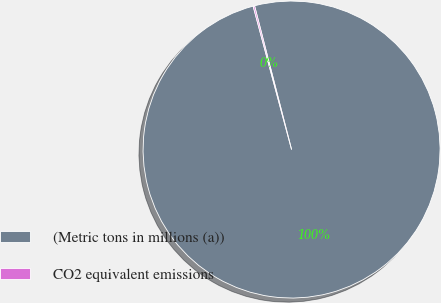Convert chart to OTSL. <chart><loc_0><loc_0><loc_500><loc_500><pie_chart><fcel>(Metric tons in millions (a))<fcel>CO2 equivalent emissions<nl><fcel>99.84%<fcel>0.16%<nl></chart> 